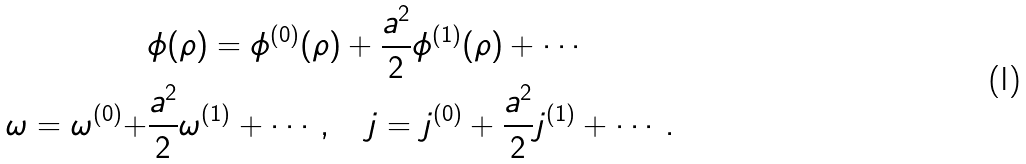Convert formula to latex. <formula><loc_0><loc_0><loc_500><loc_500>& \phi ( \rho ) = \phi ^ { ( 0 ) } ( \rho ) + \frac { a ^ { 2 } } { 2 } \phi ^ { ( 1 ) } ( \rho ) + \cdots \\ \omega = \omega ^ { ( 0 ) } + & \frac { a ^ { 2 } } { 2 } \omega ^ { ( 1 ) } + \cdots , \quad j = j ^ { ( 0 ) } + \frac { a ^ { 2 } } { 2 } j ^ { ( 1 ) } + \cdots .</formula> 